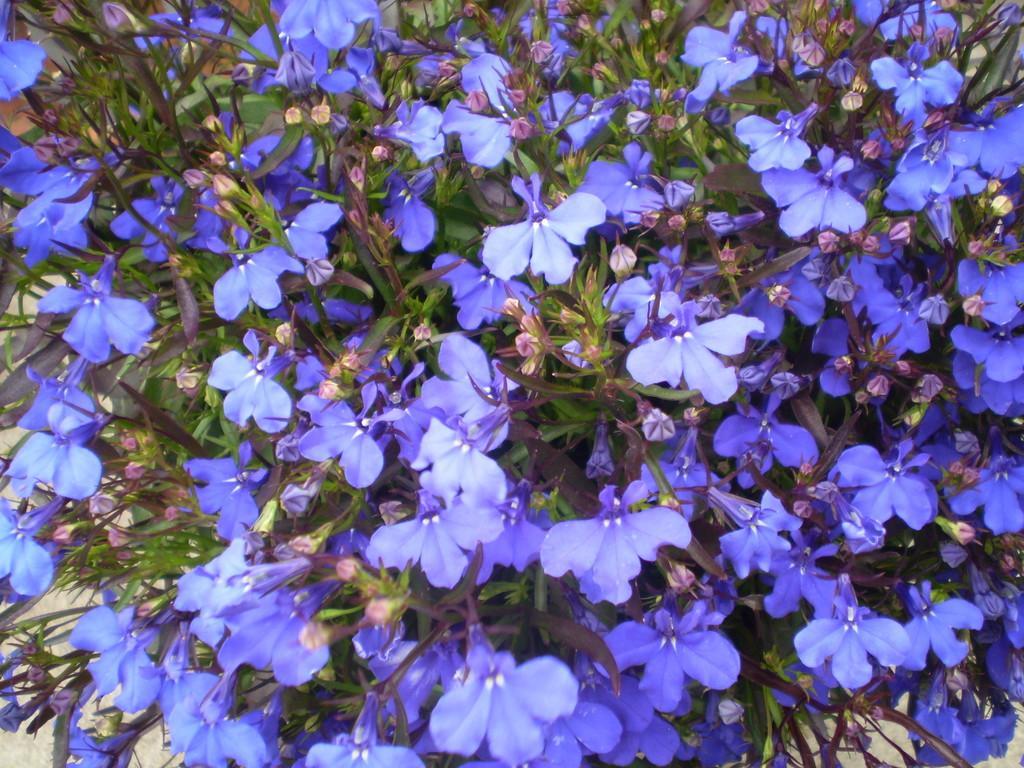Describe this image in one or two sentences. In this picture I can see plants with flowers and buds. 